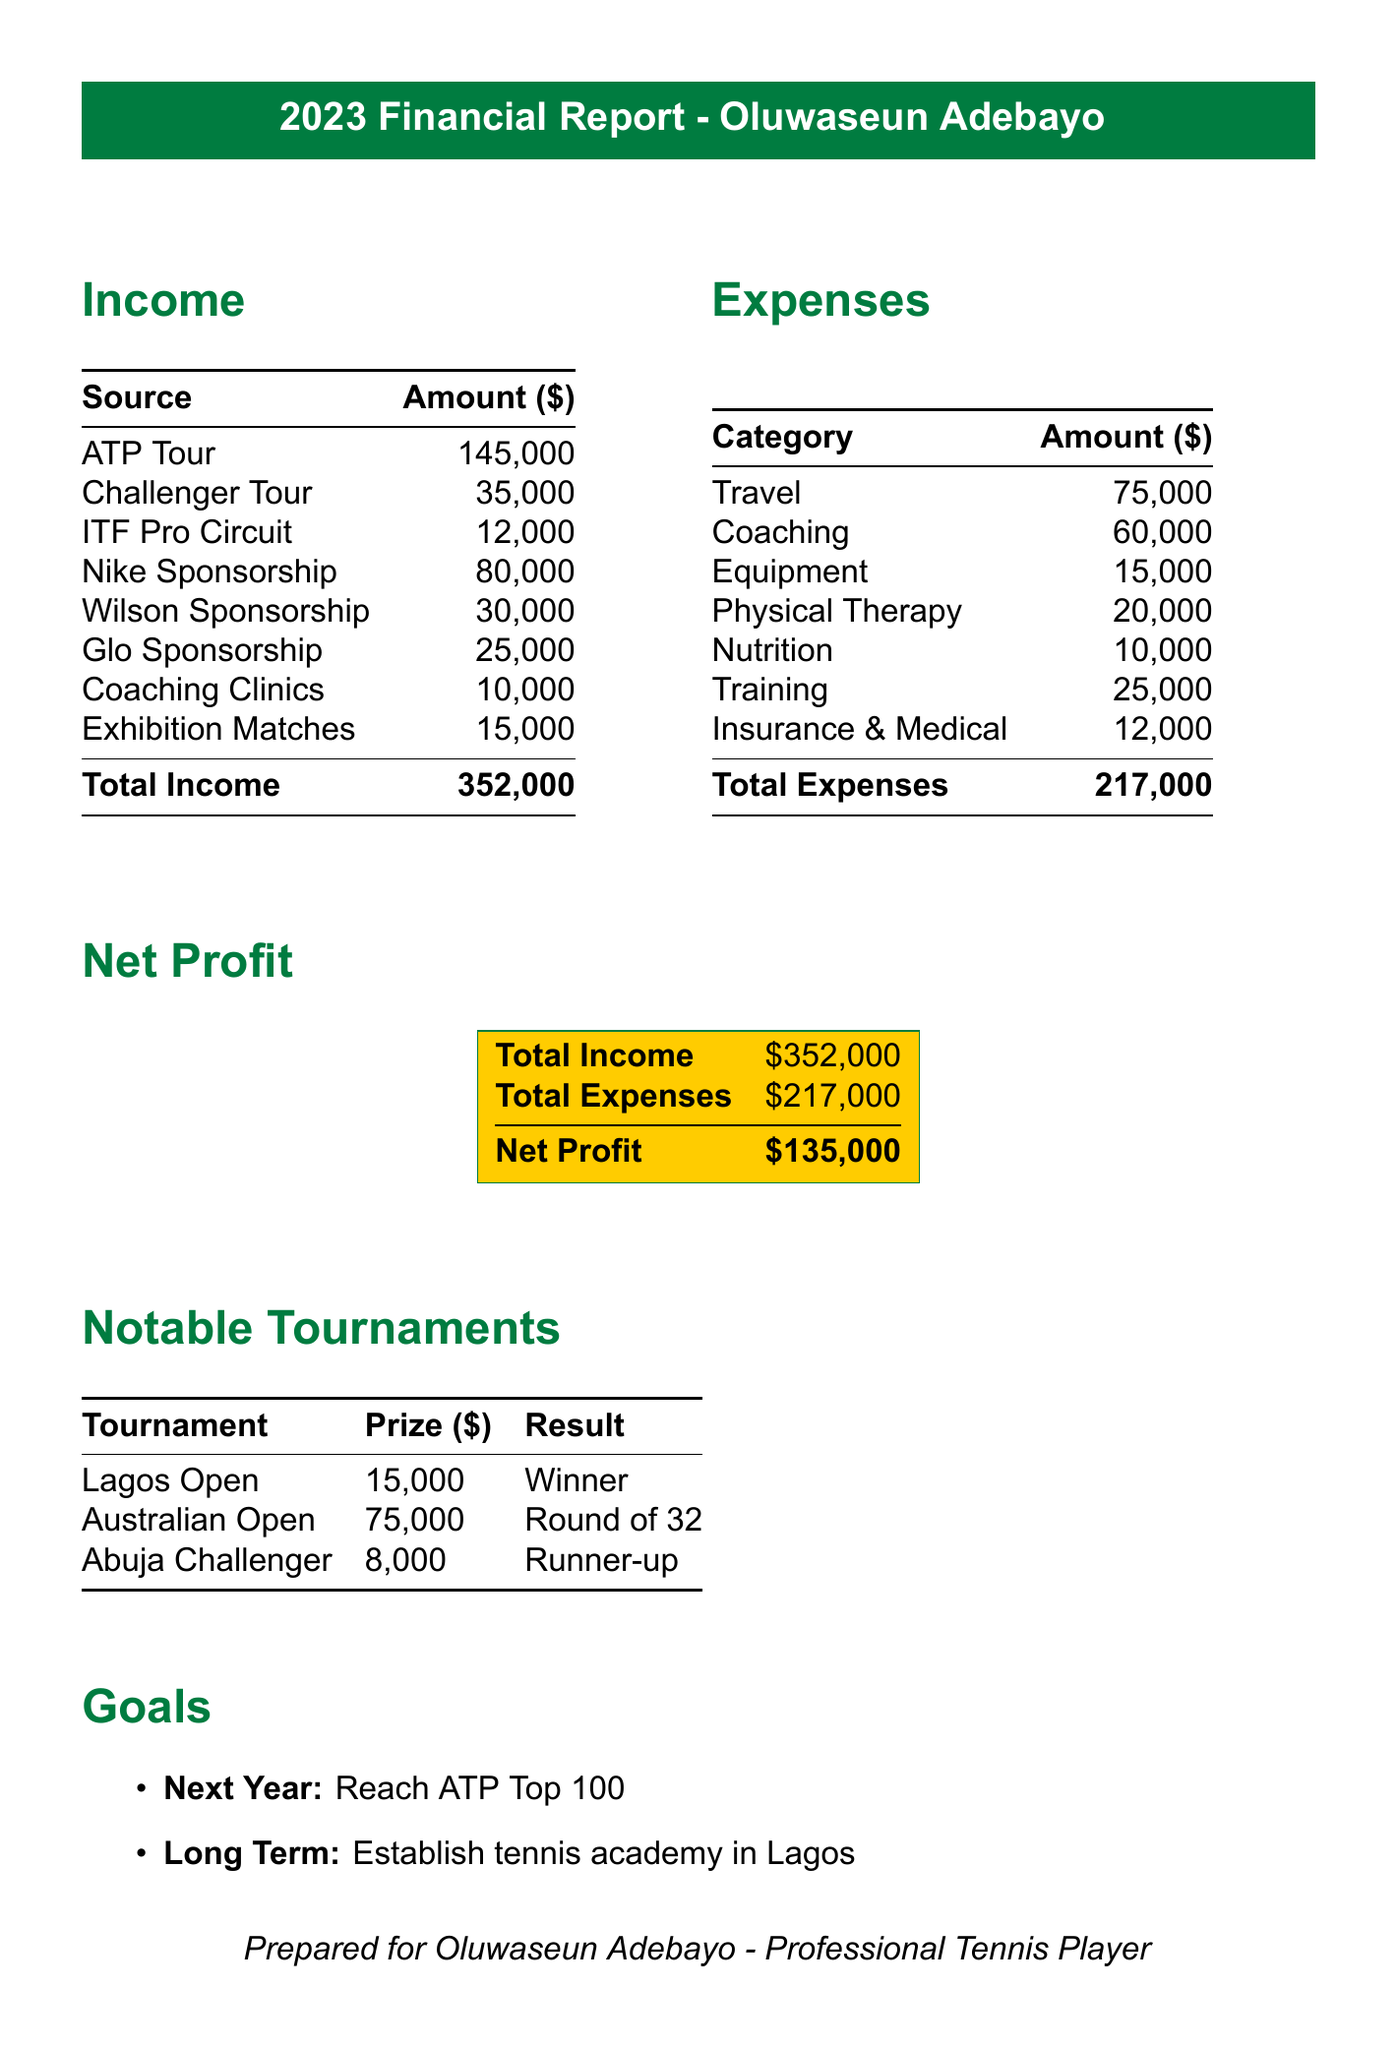What is the total income? The total income is listed at the bottom of the income section of the document, which combines all income sources.
Answer: 352000 What was the prize money for the Australian Open? The prize amount for the Australian Open is specifically mentioned in the notable tournaments section.
Answer: 75000 How much was spent on travel? The travel expense is explicitly stated in the expenses section of the document.
Answer: 75000 What was Oluwaseun's net profit? The net profit is calculated as total income minus total expenses, shown in the net profit section.
Answer: 135000 Which sponsorship contributed the most income? The Nike sponsorship amount is stated and is the highest compared to other sponsorship sources.
Answer: 80000 How much did Oluwaseun earn from exhibition matches? The income from exhibition matches is specified in the income section of the document.
Answer: 15000 What are Oluwaseun's long-term goals? The long-term goal is clearly outlined in the goals section of the document.
Answer: Establish tennis academy in Lagos How much was allocated for nutrition? The nutrition expense is listed under the expenses section of the document.
Answer: 10000 What was the result of the Lagos Open? The result for the Lagos Open is mentioned in the notable tournaments section.
Answer: Winner 